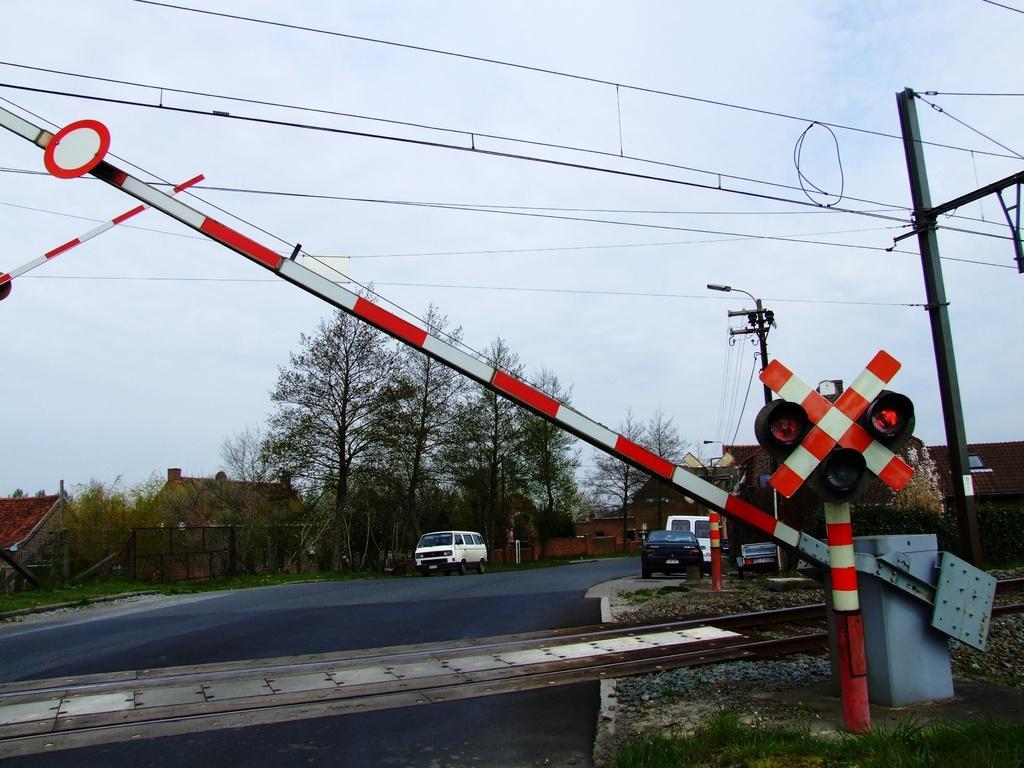Describe this image in one or two sentences. Here in this picture, in the front we can see railway track present over a place and beside that on either side we can see railway gates present and we can see vehicles present on the road and in the far we can see houses present and in the far we can see the ground is covered with grass, plants and trees and we can also see electric poles with wires hanging and we can see light posts present and we can see the sky is cloudy. 